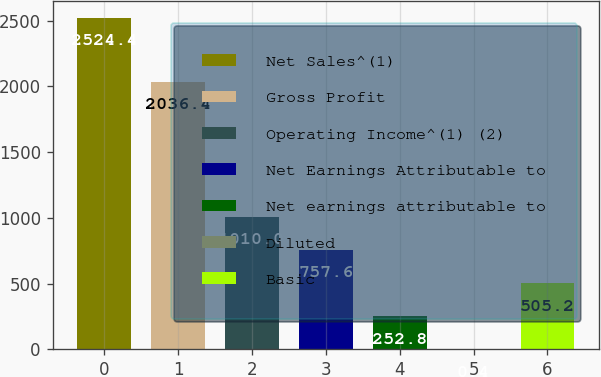<chart> <loc_0><loc_0><loc_500><loc_500><bar_chart><fcel>Net Sales^(1)<fcel>Gross Profit<fcel>Operating Income^(1) (2)<fcel>Net Earnings Attributable to<fcel>Net earnings attributable to<fcel>Diluted<fcel>Basic<nl><fcel>2524.4<fcel>2036.4<fcel>1010<fcel>757.6<fcel>252.8<fcel>0.4<fcel>505.2<nl></chart> 